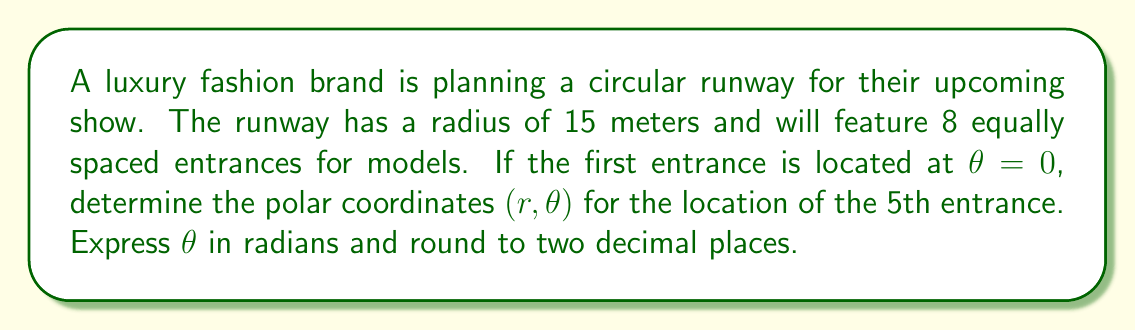Provide a solution to this math problem. To solve this problem, we need to follow these steps:

1) First, we need to understand that the runway is a complete circle, which corresponds to $2\pi$ radians.

2) Since there are 8 equally spaced entrances, we need to divide the full circle by 8 to find the angle between each entrance:

   $$\text{Angle between entrances} = \frac{2\pi}{8} = \frac{\pi}{4} \text{ radians}$$

3) The 5th entrance will be located at 4 times this angle from the first entrance (as we start counting from the 1st entrance):

   $$\text{Angle to 5th entrance} = 4 \cdot \frac{\pi}{4} = \pi \text{ radians}$$

4) In polar coordinates, the radius $r$ remains constant for all points on the circle, which in this case is 15 meters.

5) Therefore, the polar coordinates for the 5th entrance are:

   $$(r, \theta) = (15, \pi)$$

6) Rounding $\theta$ to two decimal places:

   $$\pi \approx 3.14 \text{ radians}$$

Thus, the final answer, rounded to two decimal places, is $(15, 3.14)$.
Answer: $(15, 3.14)$ 